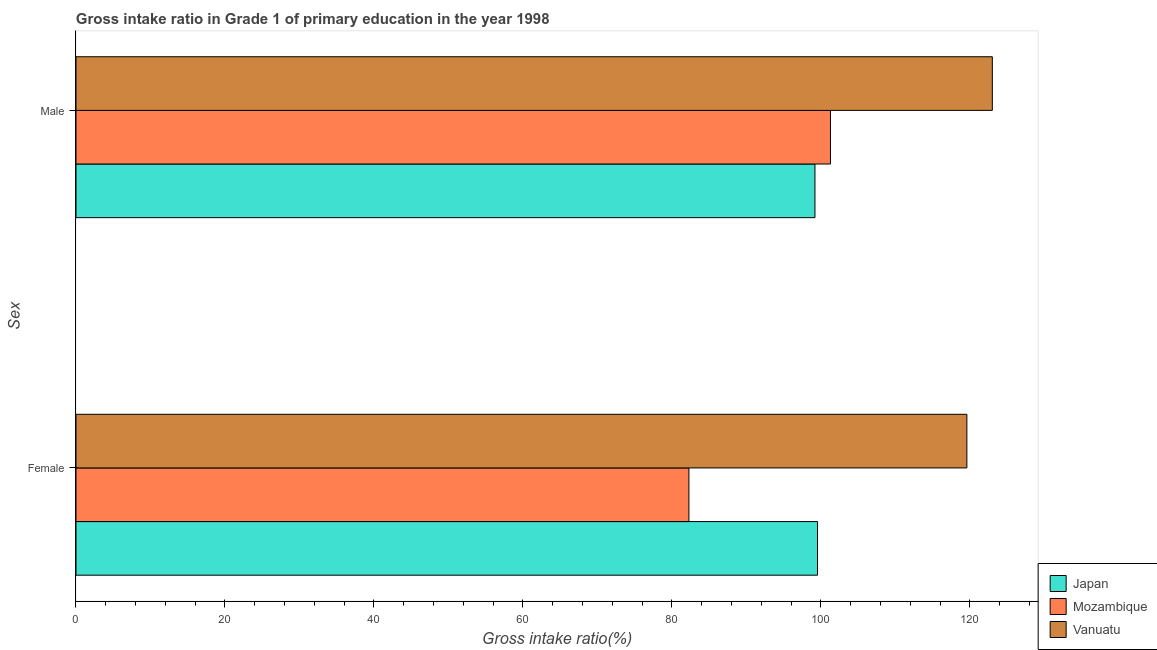How many different coloured bars are there?
Your answer should be very brief. 3. Are the number of bars per tick equal to the number of legend labels?
Your response must be concise. Yes. What is the label of the 2nd group of bars from the top?
Your answer should be compact. Female. What is the gross intake ratio(male) in Mozambique?
Provide a succinct answer. 101.29. Across all countries, what is the maximum gross intake ratio(female)?
Provide a succinct answer. 119.6. Across all countries, what is the minimum gross intake ratio(female)?
Offer a very short reply. 82.29. In which country was the gross intake ratio(male) maximum?
Your answer should be very brief. Vanuatu. In which country was the gross intake ratio(female) minimum?
Make the answer very short. Mozambique. What is the total gross intake ratio(male) in the graph?
Give a very brief answer. 323.52. What is the difference between the gross intake ratio(female) in Vanuatu and that in Japan?
Ensure brevity in your answer.  20.05. What is the difference between the gross intake ratio(male) in Japan and the gross intake ratio(female) in Mozambique?
Your answer should be compact. 16.92. What is the average gross intake ratio(female) per country?
Your answer should be very brief. 100.48. What is the difference between the gross intake ratio(female) and gross intake ratio(male) in Vanuatu?
Give a very brief answer. -3.42. What is the ratio of the gross intake ratio(male) in Mozambique to that in Vanuatu?
Make the answer very short. 0.82. Is the gross intake ratio(female) in Mozambique less than that in Vanuatu?
Give a very brief answer. Yes. In how many countries, is the gross intake ratio(male) greater than the average gross intake ratio(male) taken over all countries?
Your response must be concise. 1. What does the 1st bar from the top in Male represents?
Your answer should be compact. Vanuatu. What does the 2nd bar from the bottom in Female represents?
Offer a very short reply. Mozambique. How many countries are there in the graph?
Your response must be concise. 3. Are the values on the major ticks of X-axis written in scientific E-notation?
Your response must be concise. No. Does the graph contain grids?
Offer a very short reply. No. Where does the legend appear in the graph?
Make the answer very short. Bottom right. How many legend labels are there?
Keep it short and to the point. 3. What is the title of the graph?
Make the answer very short. Gross intake ratio in Grade 1 of primary education in the year 1998. What is the label or title of the X-axis?
Your response must be concise. Gross intake ratio(%). What is the label or title of the Y-axis?
Ensure brevity in your answer.  Sex. What is the Gross intake ratio(%) in Japan in Female?
Your answer should be compact. 99.55. What is the Gross intake ratio(%) in Mozambique in Female?
Your answer should be compact. 82.29. What is the Gross intake ratio(%) in Vanuatu in Female?
Give a very brief answer. 119.6. What is the Gross intake ratio(%) of Japan in Male?
Make the answer very short. 99.21. What is the Gross intake ratio(%) of Mozambique in Male?
Make the answer very short. 101.29. What is the Gross intake ratio(%) of Vanuatu in Male?
Offer a very short reply. 123.02. Across all Sex, what is the maximum Gross intake ratio(%) of Japan?
Your response must be concise. 99.55. Across all Sex, what is the maximum Gross intake ratio(%) of Mozambique?
Offer a very short reply. 101.29. Across all Sex, what is the maximum Gross intake ratio(%) of Vanuatu?
Give a very brief answer. 123.02. Across all Sex, what is the minimum Gross intake ratio(%) of Japan?
Ensure brevity in your answer.  99.21. Across all Sex, what is the minimum Gross intake ratio(%) in Mozambique?
Offer a very short reply. 82.29. Across all Sex, what is the minimum Gross intake ratio(%) of Vanuatu?
Your answer should be very brief. 119.6. What is the total Gross intake ratio(%) in Japan in the graph?
Keep it short and to the point. 198.76. What is the total Gross intake ratio(%) in Mozambique in the graph?
Provide a succinct answer. 183.57. What is the total Gross intake ratio(%) in Vanuatu in the graph?
Make the answer very short. 242.62. What is the difference between the Gross intake ratio(%) in Japan in Female and that in Male?
Offer a terse response. 0.35. What is the difference between the Gross intake ratio(%) of Mozambique in Female and that in Male?
Provide a succinct answer. -19. What is the difference between the Gross intake ratio(%) of Vanuatu in Female and that in Male?
Keep it short and to the point. -3.42. What is the difference between the Gross intake ratio(%) in Japan in Female and the Gross intake ratio(%) in Mozambique in Male?
Provide a short and direct response. -1.74. What is the difference between the Gross intake ratio(%) of Japan in Female and the Gross intake ratio(%) of Vanuatu in Male?
Offer a terse response. -23.47. What is the difference between the Gross intake ratio(%) in Mozambique in Female and the Gross intake ratio(%) in Vanuatu in Male?
Keep it short and to the point. -40.73. What is the average Gross intake ratio(%) in Japan per Sex?
Offer a terse response. 99.38. What is the average Gross intake ratio(%) in Mozambique per Sex?
Offer a very short reply. 91.79. What is the average Gross intake ratio(%) of Vanuatu per Sex?
Keep it short and to the point. 121.31. What is the difference between the Gross intake ratio(%) in Japan and Gross intake ratio(%) in Mozambique in Female?
Your answer should be very brief. 17.27. What is the difference between the Gross intake ratio(%) of Japan and Gross intake ratio(%) of Vanuatu in Female?
Your response must be concise. -20.05. What is the difference between the Gross intake ratio(%) in Mozambique and Gross intake ratio(%) in Vanuatu in Female?
Your answer should be very brief. -37.32. What is the difference between the Gross intake ratio(%) of Japan and Gross intake ratio(%) of Mozambique in Male?
Provide a succinct answer. -2.08. What is the difference between the Gross intake ratio(%) in Japan and Gross intake ratio(%) in Vanuatu in Male?
Make the answer very short. -23.81. What is the difference between the Gross intake ratio(%) of Mozambique and Gross intake ratio(%) of Vanuatu in Male?
Your answer should be compact. -21.73. What is the ratio of the Gross intake ratio(%) in Mozambique in Female to that in Male?
Offer a terse response. 0.81. What is the ratio of the Gross intake ratio(%) of Vanuatu in Female to that in Male?
Provide a succinct answer. 0.97. What is the difference between the highest and the second highest Gross intake ratio(%) in Japan?
Provide a short and direct response. 0.35. What is the difference between the highest and the second highest Gross intake ratio(%) of Mozambique?
Give a very brief answer. 19. What is the difference between the highest and the second highest Gross intake ratio(%) of Vanuatu?
Your response must be concise. 3.42. What is the difference between the highest and the lowest Gross intake ratio(%) in Japan?
Your answer should be compact. 0.35. What is the difference between the highest and the lowest Gross intake ratio(%) of Mozambique?
Give a very brief answer. 19. What is the difference between the highest and the lowest Gross intake ratio(%) in Vanuatu?
Make the answer very short. 3.42. 